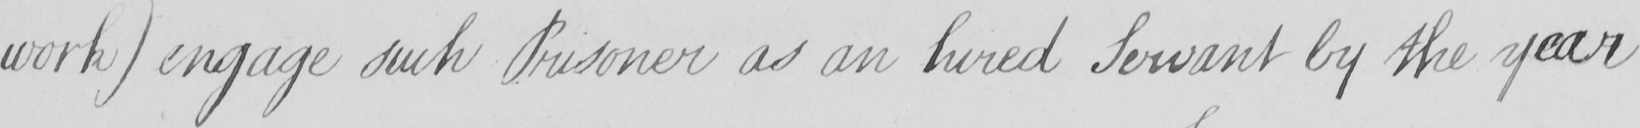Can you read and transcribe this handwriting? work )  engage such Prisoner as an hired Servant by the year 